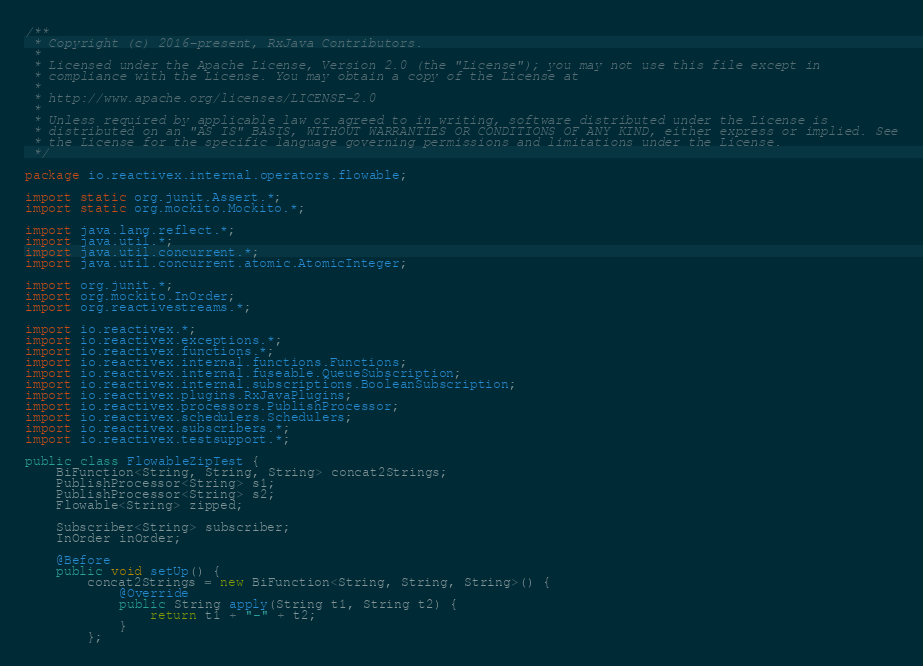<code> <loc_0><loc_0><loc_500><loc_500><_Java_>/**
 * Copyright (c) 2016-present, RxJava Contributors.
 *
 * Licensed under the Apache License, Version 2.0 (the "License"); you may not use this file except in
 * compliance with the License. You may obtain a copy of the License at
 *
 * http://www.apache.org/licenses/LICENSE-2.0
 *
 * Unless required by applicable law or agreed to in writing, software distributed under the License is
 * distributed on an "AS IS" BASIS, WITHOUT WARRANTIES OR CONDITIONS OF ANY KIND, either express or implied. See
 * the License for the specific language governing permissions and limitations under the License.
 */

package io.reactivex.internal.operators.flowable;

import static org.junit.Assert.*;
import static org.mockito.Mockito.*;

import java.lang.reflect.*;
import java.util.*;
import java.util.concurrent.*;
import java.util.concurrent.atomic.AtomicInteger;

import org.junit.*;
import org.mockito.InOrder;
import org.reactivestreams.*;

import io.reactivex.*;
import io.reactivex.exceptions.*;
import io.reactivex.functions.*;
import io.reactivex.internal.functions.Functions;
import io.reactivex.internal.fuseable.QueueSubscription;
import io.reactivex.internal.subscriptions.BooleanSubscription;
import io.reactivex.plugins.RxJavaPlugins;
import io.reactivex.processors.PublishProcessor;
import io.reactivex.schedulers.Schedulers;
import io.reactivex.subscribers.*;
import io.reactivex.testsupport.*;

public class FlowableZipTest {
    BiFunction<String, String, String> concat2Strings;
    PublishProcessor<String> s1;
    PublishProcessor<String> s2;
    Flowable<String> zipped;

    Subscriber<String> subscriber;
    InOrder inOrder;

    @Before
    public void setUp() {
        concat2Strings = new BiFunction<String, String, String>() {
            @Override
            public String apply(String t1, String t2) {
                return t1 + "-" + t2;
            }
        };
</code> 